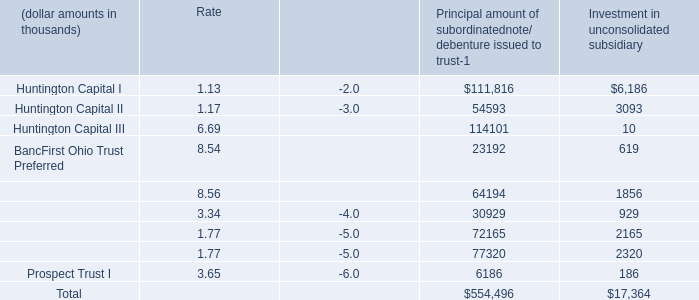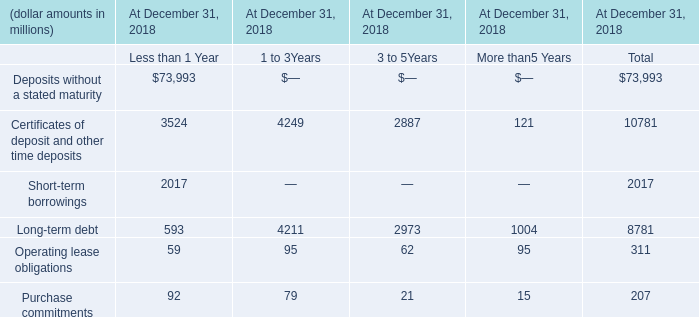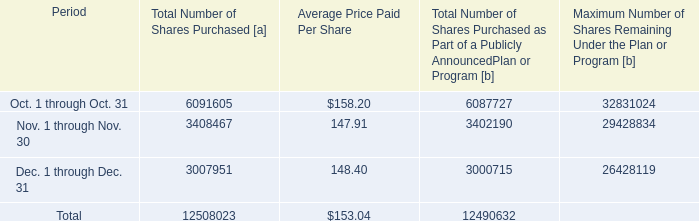what percent of share repurchases took place in the fourth quarter? 
Computations: (12508023 / 57669746)
Answer: 0.21689. 